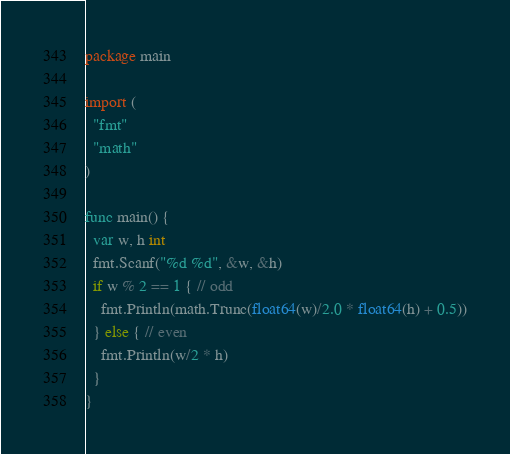<code> <loc_0><loc_0><loc_500><loc_500><_Go_>package main

import (
  "fmt"
  "math"
)

func main() {
  var w, h int
  fmt.Scanf("%d %d", &w, &h)
  if w % 2 == 1 { // odd
    fmt.Println(math.Trunc(float64(w)/2.0 * float64(h) + 0.5))
  } else { // even
    fmt.Println(w/2 * h)
  }
}</code> 